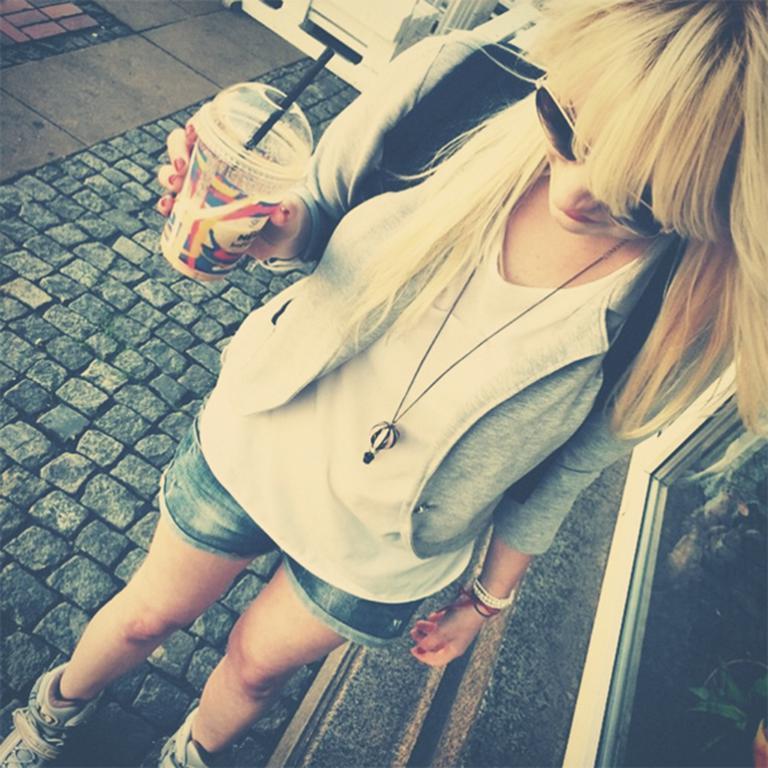Could you give a brief overview of what you see in this image? In this picture we can see a woman is standing on the path and the woman is holding a cup and in the cup there is a straw. On the right side of the woman there is a window. 